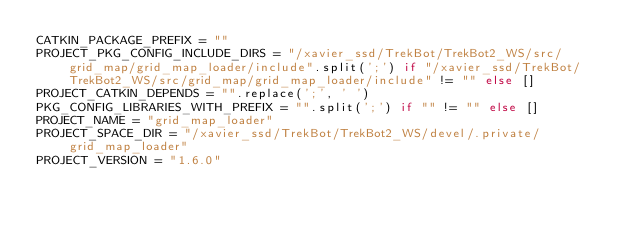Convert code to text. <code><loc_0><loc_0><loc_500><loc_500><_Python_>CATKIN_PACKAGE_PREFIX = ""
PROJECT_PKG_CONFIG_INCLUDE_DIRS = "/xavier_ssd/TrekBot/TrekBot2_WS/src/grid_map/grid_map_loader/include".split(';') if "/xavier_ssd/TrekBot/TrekBot2_WS/src/grid_map/grid_map_loader/include" != "" else []
PROJECT_CATKIN_DEPENDS = "".replace(';', ' ')
PKG_CONFIG_LIBRARIES_WITH_PREFIX = "".split(';') if "" != "" else []
PROJECT_NAME = "grid_map_loader"
PROJECT_SPACE_DIR = "/xavier_ssd/TrekBot/TrekBot2_WS/devel/.private/grid_map_loader"
PROJECT_VERSION = "1.6.0"
</code> 